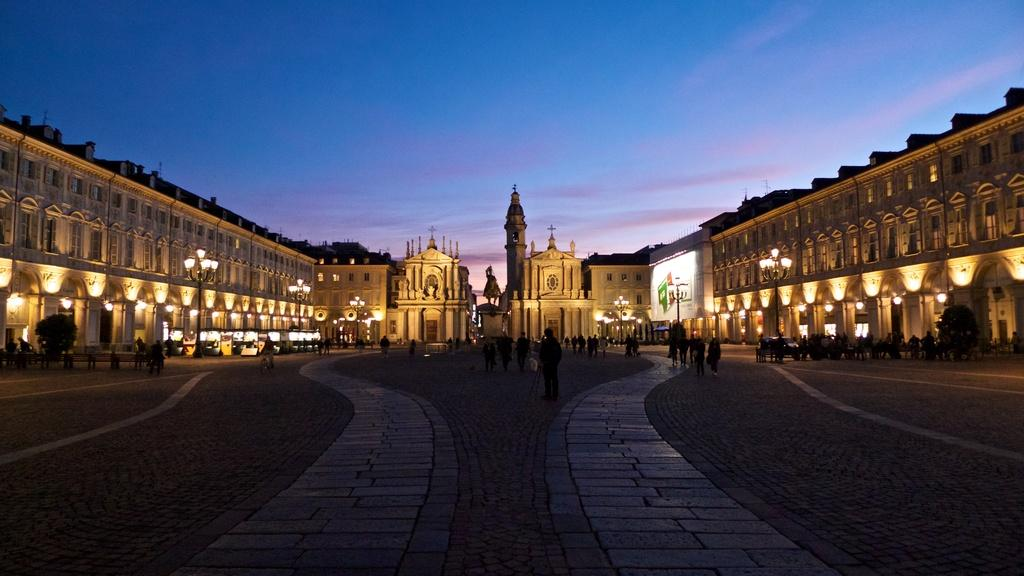What type of structures can be seen in the image? There are buildings in the image. What else is visible in the image besides the buildings? There are lights, people on the road, and a statue in the center of the image. What is visible at the top of the image? The sky is visible at the top of the image. Can you see any snails crawling on the statue in the image? There are no snails visible on the statue in the image. What type of dirt can be seen on the road in the image? There is no dirt visible on the road in the image; it appears to be a clean surface. 